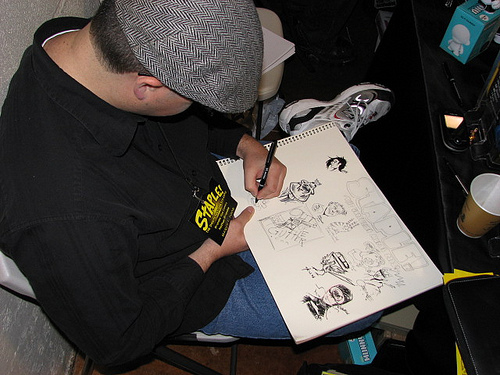<image>
Is there a man under the sketch pad? Yes. The man is positioned underneath the sketch pad, with the sketch pad above it in the vertical space. 